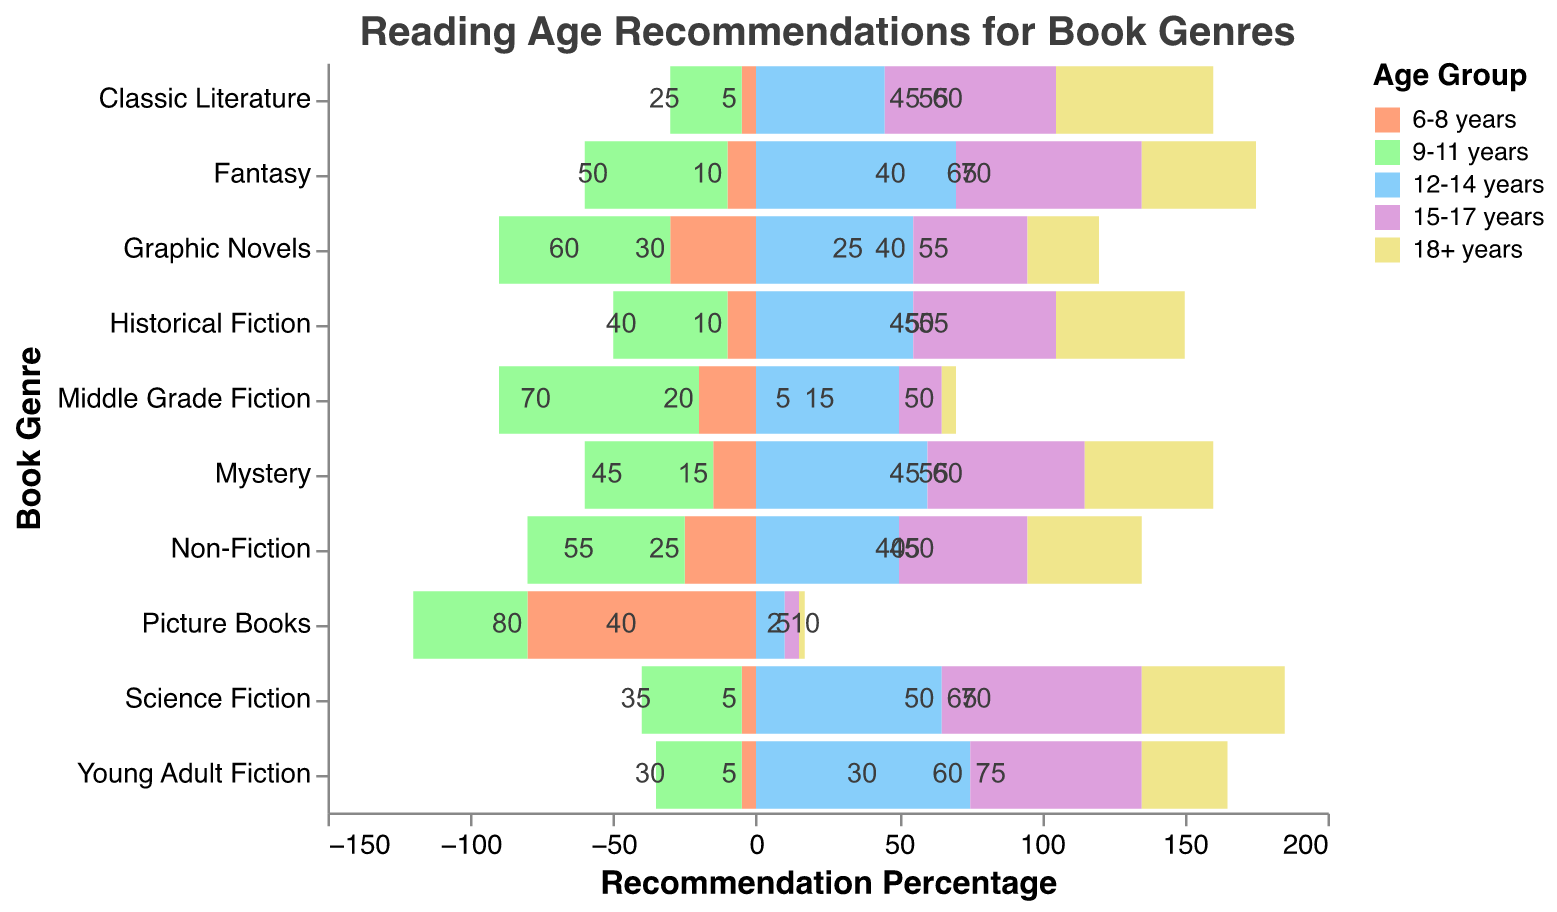What's the most recommended genre for the age group 12-14 years? Look for which genre has the highest value among the 12-14 years age group. "Young Adult Fiction" has the highest value of 75.
Answer: Young Adult Fiction Which genre has the highest percentage recommendation for the age group 6-8 years? Check all the values for the 6-8 years age group. "Picture Books" has the highest value of 80.
Answer: Picture Books Which genre is least recommended for the age group 18+ years? Check all the values for the 18+ years age group. "Picture Books" has the lowest value of 2.
Answer: Picture Books What is the total percentage recommendation for "Fantasy" across all age groups? Sum the values of "Fantasy" across all age groups: 10 + 50 + 70 + 65 + 40 = 235.
Answer: 235 Between "Science Fiction" and "Classic Literature," which genre is more recommended for the age group 15-17 years? Compare the values for the 15-17 years age group. "Science Fiction" has a value of 70, and "Classic Literature" has a value of 60.
Answer: Science Fiction What is the difference in percentage recommendation between "Mystery" and "Historical Fiction" for 12-14 years? Subtract the value for "Historical Fiction" from "Mystery" in the 12-14 years age group: 60 - 55 = 5.
Answer: 5 Which genres have equal recommendations across any age group? Identify genres with equal values across the same age group. No genres have exact equal values across age groups.
Answer: None What is the average percentage recommendation for "Non-Fiction" across the age groups? Sum the values for "Non-Fiction," which equals 215, and divide by the number of age groups (5): 215/5 = 43.
Answer: 43 How does the recommendation for "Graphic Novels" for the age group 9-11 years compare to "Middle Grade Fiction" for the same age group? Compare the values for both genres in the 9-11 years age group. "Graphic Novels" has a value of 60 and "Middle Grade Fiction" has a value of 70.
Answer: Middle Grade Fiction has a higher value Which age group has the lowest percentage recommendation for "Young Adult Fiction"? Look at all the values for "Young Adult Fiction" and identify the lowest. The 6-8 years age group has a value of 5.
Answer: 6-8 years In the figure, what stands out as the most universally appealing genre (considering all age groups)? A universally appealing genre would have high values across all age groups. "Fantasy" and "Mystery" have high values across a broad range of age groups but "Fantasy" has the highest overall recommendation.
Answer: Fantasy 